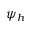Convert formula to latex. <formula><loc_0><loc_0><loc_500><loc_500>\psi _ { h }</formula> 